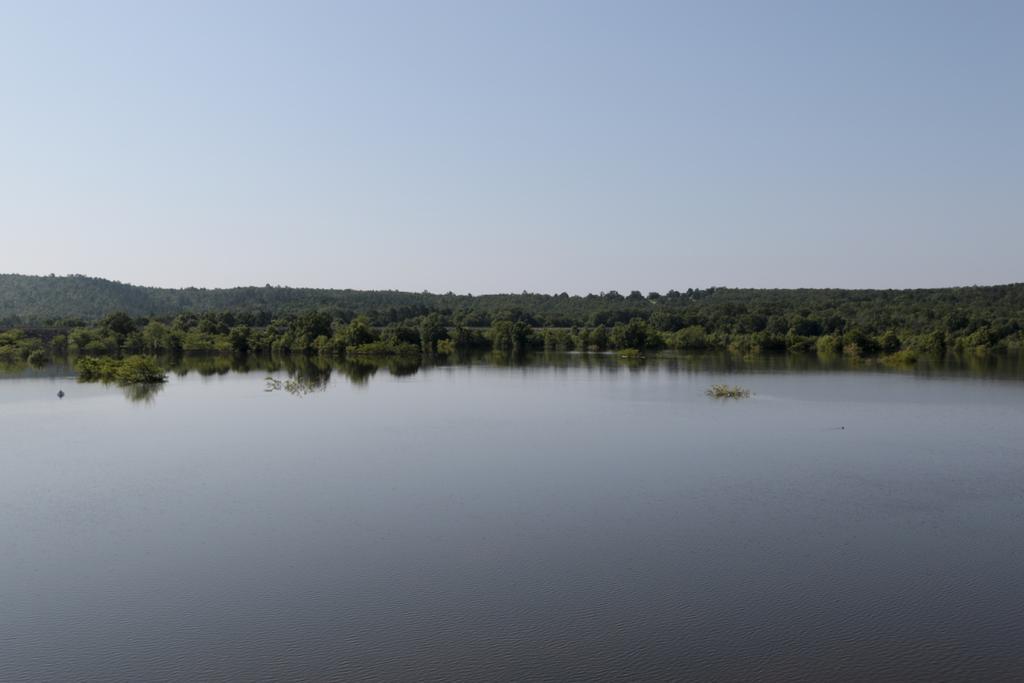Describe this image in one or two sentences. In this image we can see a lake, trees and sky. 